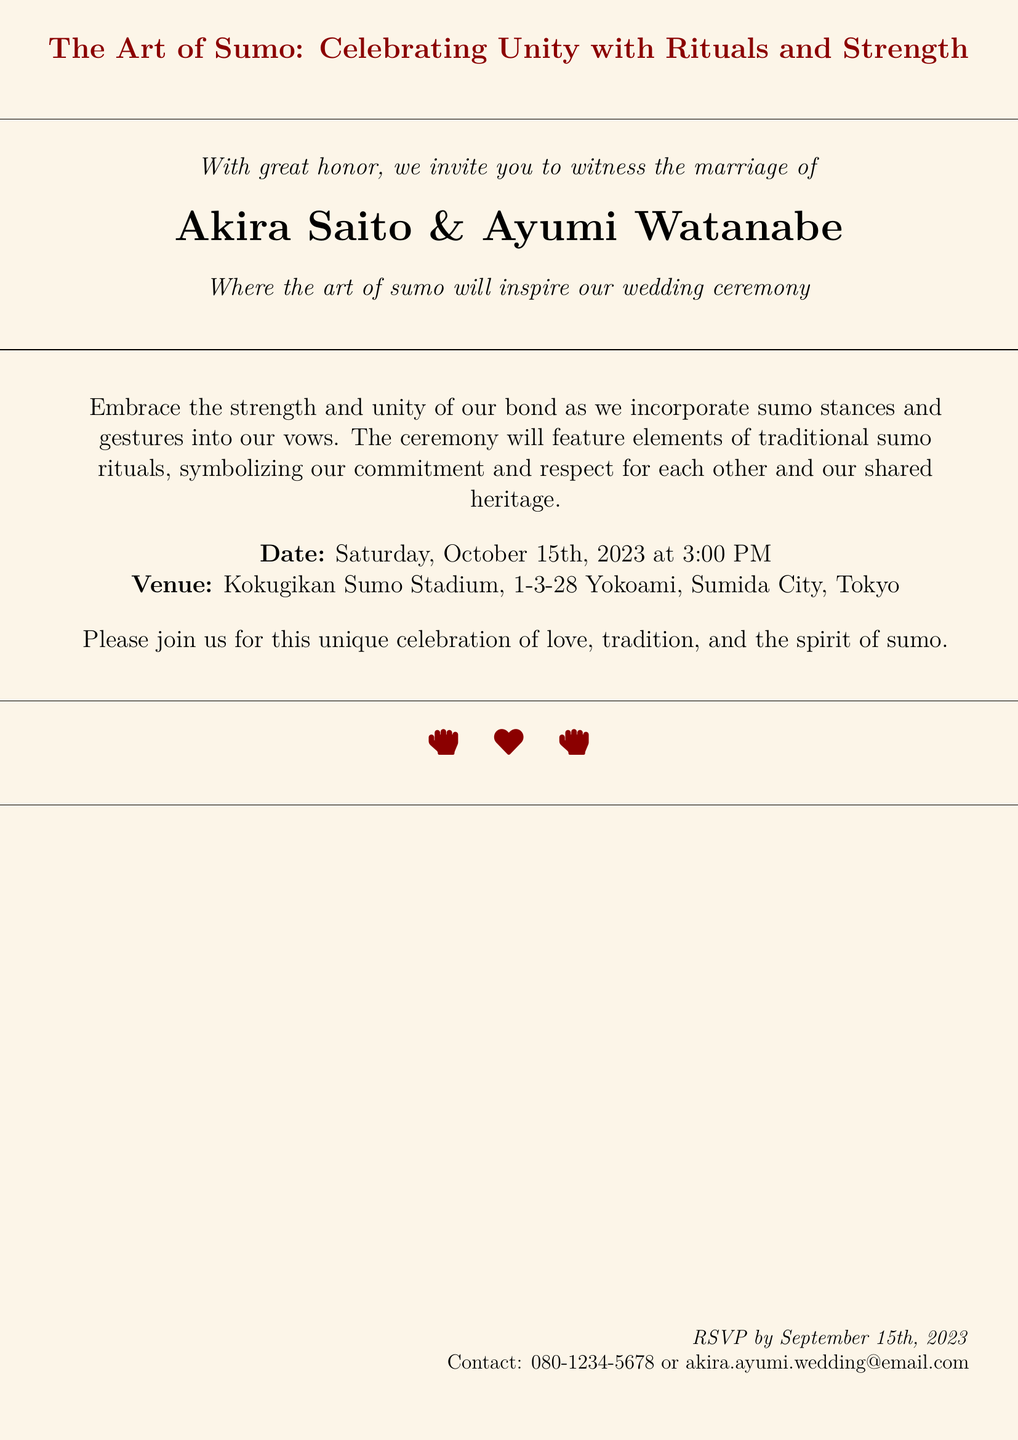What is the full name of the groom? The document states the groom's full name as Akira Saito.
Answer: Akira Saito What is the full name of the bride? The document lists the bride's full name as Ayumi Watanabe.
Answer: Ayumi Watanabe What is the date of the wedding ceremony? The date mentioned in the document for the ceremony is October 15th, 2023.
Answer: October 15th, 2023 What time is the wedding ceremony scheduled? The document specifies that the ceremony starts at 3:00 PM.
Answer: 3:00 PM Where will the wedding take place? The venue stated in the document is Kokugikan Sumo Stadium, Tokyo.
Answer: Kokugikan Sumo Stadium, Tokyo What cultural element is emphasized in the wedding? The invitation emphasizes the art of sumo as a key cultural element.
Answer: Art of sumo What is the RSVP deadline? According to the document, the deadline to RSVP is September 15th, 2023.
Answer: September 15th, 2023 What is the contact method provided for RSVP? The document offers an email address for RSVP contact.
Answer: akira.ayumi.wedding@email.com How is strength portrayed in the wedding ceremony? The strength in the ceremony is portrayed through sumo stances and gestures.
Answer: Sumo stances and gestures 